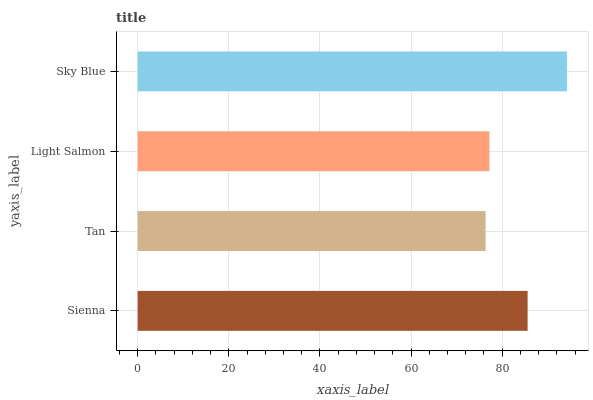Is Tan the minimum?
Answer yes or no. Yes. Is Sky Blue the maximum?
Answer yes or no. Yes. Is Light Salmon the minimum?
Answer yes or no. No. Is Light Salmon the maximum?
Answer yes or no. No. Is Light Salmon greater than Tan?
Answer yes or no. Yes. Is Tan less than Light Salmon?
Answer yes or no. Yes. Is Tan greater than Light Salmon?
Answer yes or no. No. Is Light Salmon less than Tan?
Answer yes or no. No. Is Sienna the high median?
Answer yes or no. Yes. Is Light Salmon the low median?
Answer yes or no. Yes. Is Sky Blue the high median?
Answer yes or no. No. Is Tan the low median?
Answer yes or no. No. 